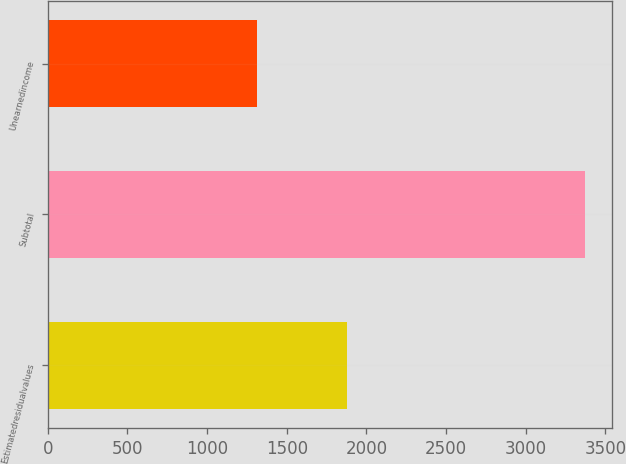Convert chart. <chart><loc_0><loc_0><loc_500><loc_500><bar_chart><fcel>Estimatedresidualvalues<fcel>Subtotal<fcel>Unearnedincome<nl><fcel>1881<fcel>3372<fcel>1313<nl></chart> 